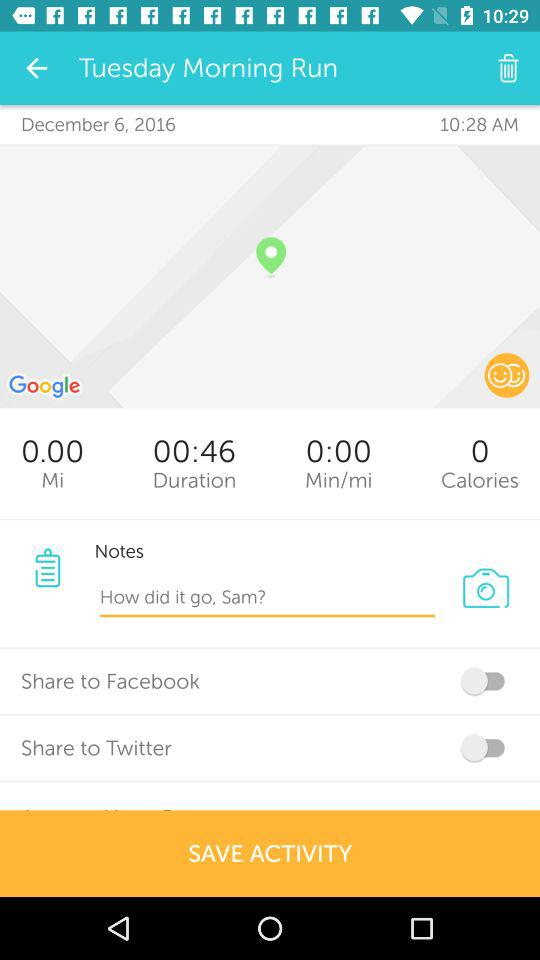What is the status of "Share to Facebook"? The status of "Share to Facebook" is "off". 